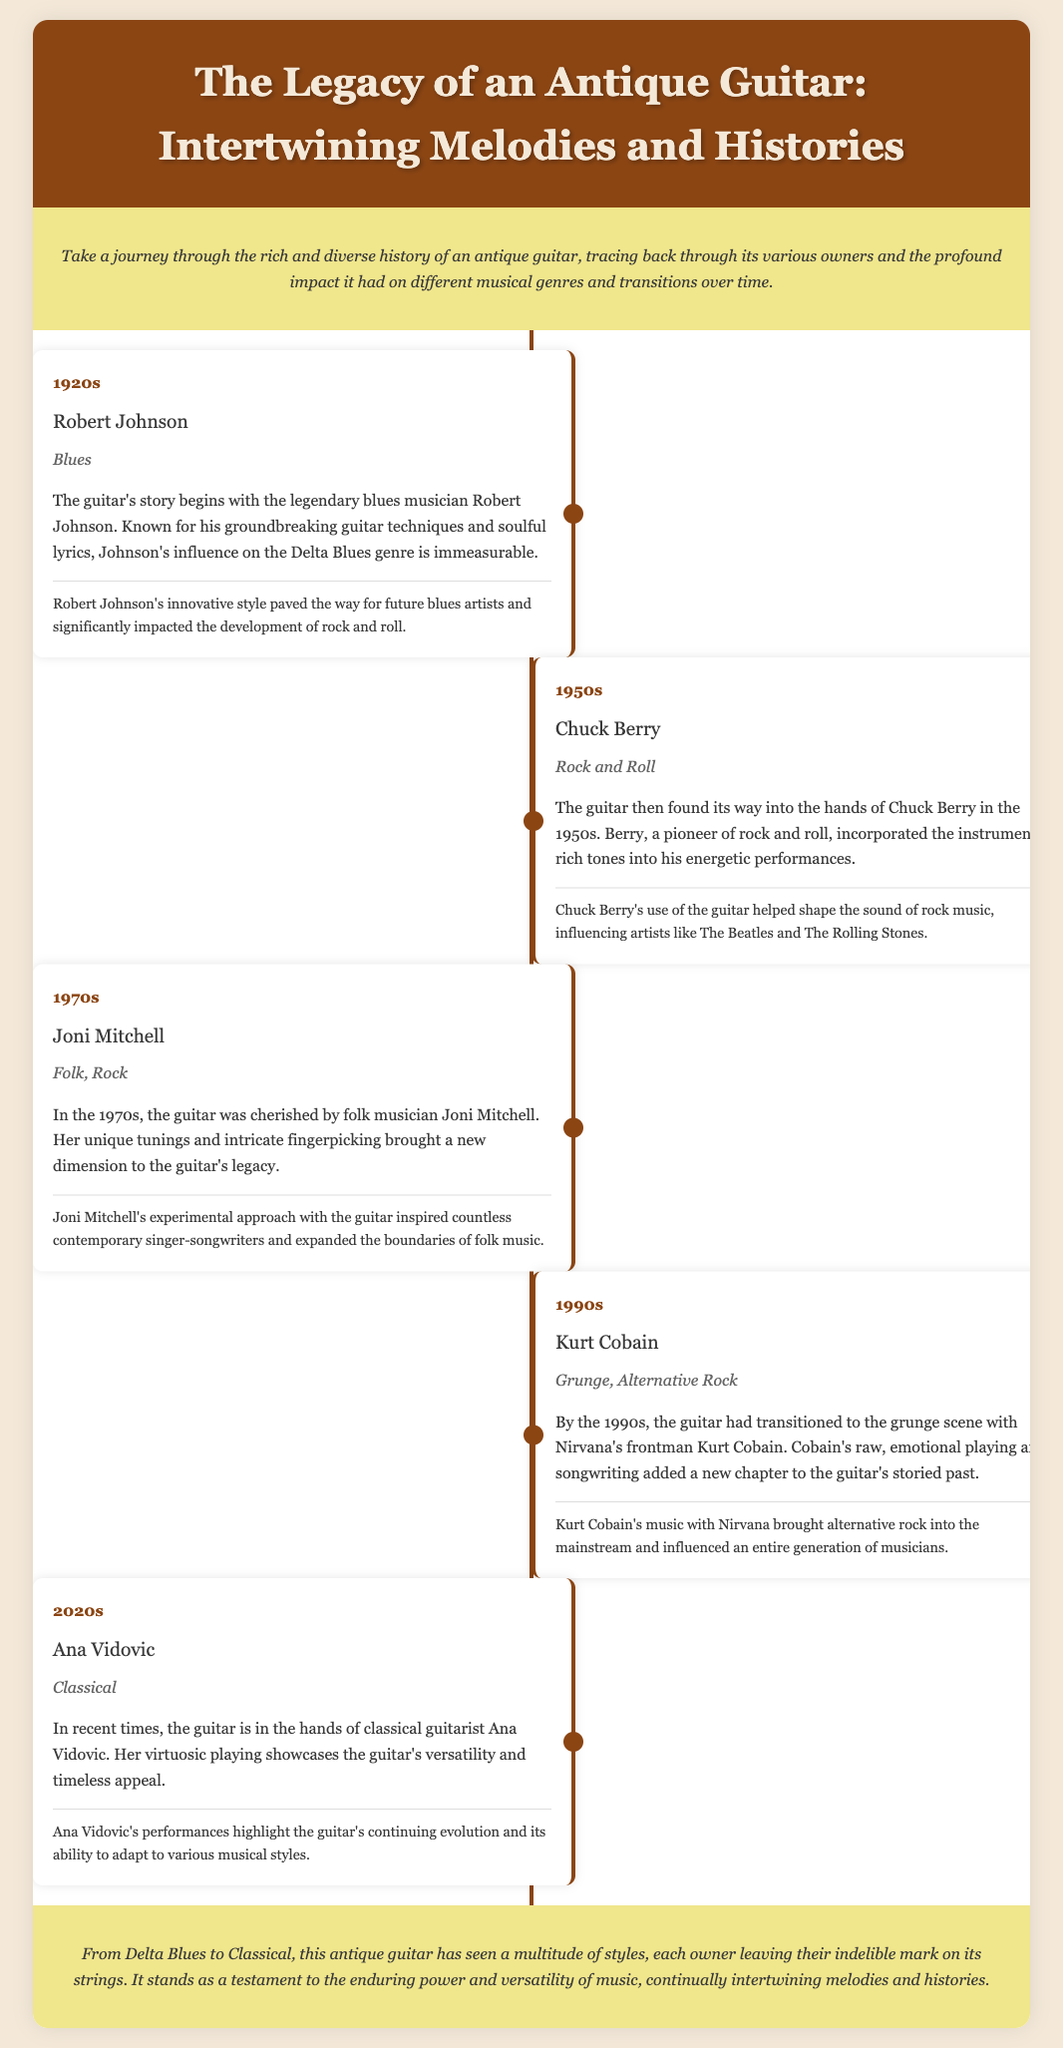What decade did Robert Johnson own the guitar? Robert Johnson is listed as the owner in the 1920s section of the timeline.
Answer: 1920s Which genre did Chuck Berry represent when he owned the guitar? The document states that Chuck Berry represented the Rock and Roll genre during the 1950s.
Answer: Rock and Roll Who is the most recent owner of the guitar mentioned? The last entry in the timeline references Ana Vidovic as the current owner in the 2020s.
Answer: Ana Vidovic What style did Joni Mitchell influence with her guitar playing? The document indicates Joni Mitchell's influence expanded the boundaries of folk music in the 1970s.
Answer: Folk music How many decades are covered in the guitar's ownership timeline? The timeline provides entries from the 1920s to the 2020s, covering a span of 5 decades.
Answer: 5 What influential musical figure is associated with the genre of Grunge? Kurt Cobain is specifically mentioned in relation to the Grunge genre in the 1990s section.
Answer: Kurt Cobain Which owner used innovative guitar techniques in the 1920s? The entry for Robert Johnson notes his groundbreaking guitar techniques.
Answer: Robert Johnson What is the overarching theme of the guitar's history as presented in the document? The conclusion highlights the enduring power and versatility of music as the main theme.
Answer: Enduring power and versatility of music 